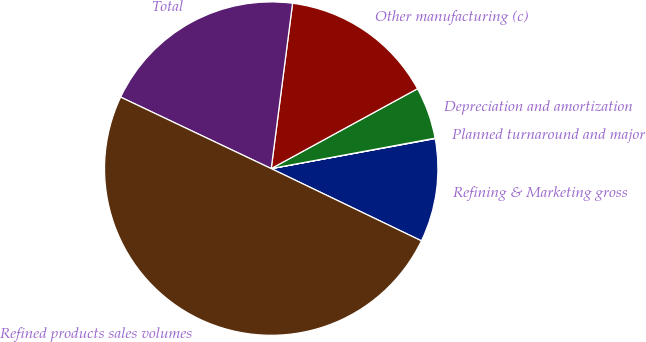Convert chart. <chart><loc_0><loc_0><loc_500><loc_500><pie_chart><fcel>Refining & Marketing gross<fcel>Planned turnaround and major<fcel>Depreciation and amortization<fcel>Other manufacturing (c)<fcel>Total<fcel>Refined products sales volumes<nl><fcel>10.02%<fcel>0.04%<fcel>5.03%<fcel>15.0%<fcel>19.99%<fcel>49.92%<nl></chart> 